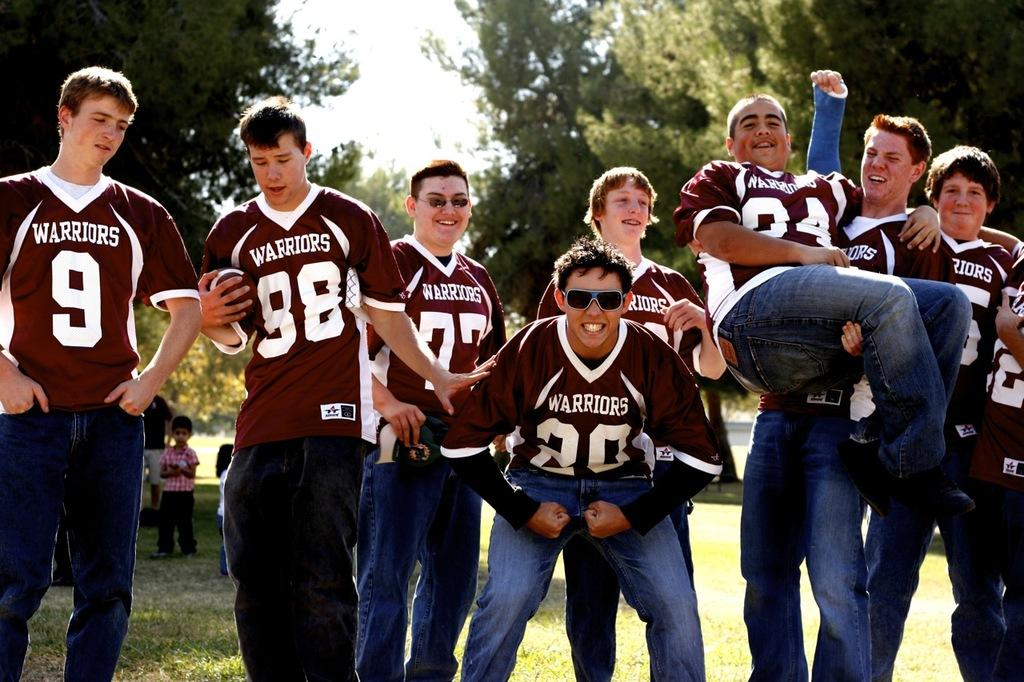<image>
Describe the image concisely. a boy with the number 20 and a group of football players posing for a photo 